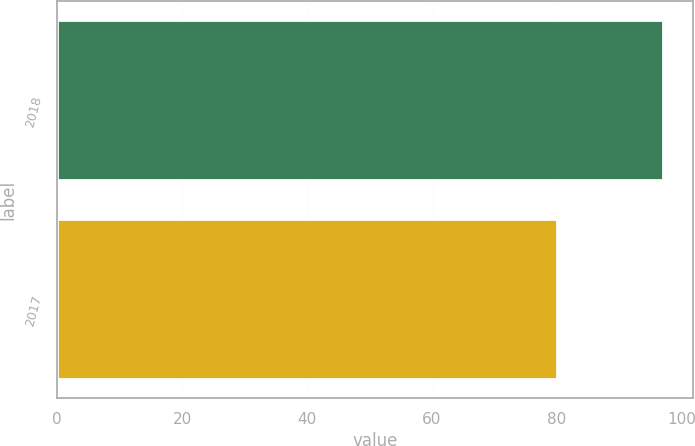Convert chart. <chart><loc_0><loc_0><loc_500><loc_500><bar_chart><fcel>2018<fcel>2017<nl><fcel>96.97<fcel>80.02<nl></chart> 